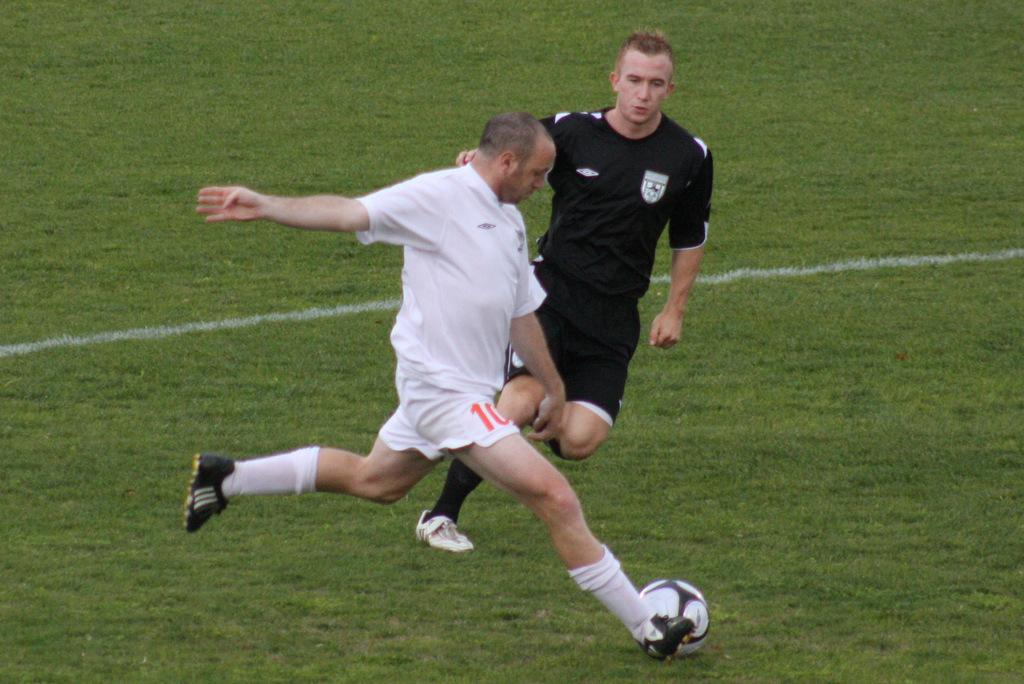Where was the image taken? The image is taken outdoors. What can be seen on the ground in the image? There is a ground with grass in the image. What are the two men in the image doing? The men are running in the image. What are the men trying to do while running? A: The men are trying to hit a ball. What type of quiver can be seen in the hands of the men in the image? There is no quiver present in the image; the men are running and trying to hit a ball, not using any archery equipment. 